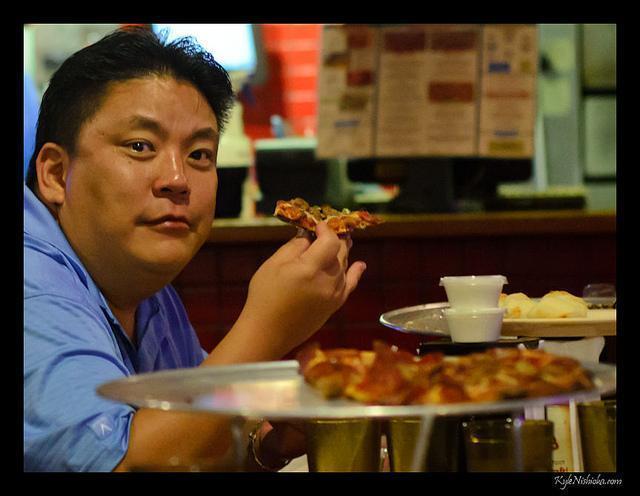How many people are visible in the image?
Give a very brief answer. 1. How many cups are in the picture?
Give a very brief answer. 4. How many pizzas can you see?
Give a very brief answer. 2. 